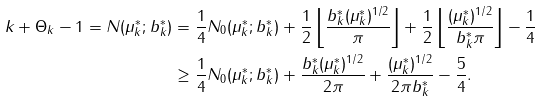Convert formula to latex. <formula><loc_0><loc_0><loc_500><loc_500>k + \Theta _ { k } - 1 = N ( \mu _ { k } ^ { * } ; b _ { k } ^ { * } ) & = \frac { 1 } { 4 } N _ { 0 } ( \mu _ { k } ^ { * } ; b _ { k } ^ { * } ) + \frac { 1 } { 2 } \left \lfloor \frac { { b _ { k } ^ { * } } ( \mu _ { k } ^ { * } ) ^ { 1 / 2 } } { \pi } \right \rfloor + \frac { 1 } { 2 } \left \lfloor \frac { ( \mu _ { k } ^ { * } ) ^ { 1 / 2 } } { b _ { k } ^ { * } \pi } \right \rfloor - \frac { 1 } { 4 } \\ & \geq \frac { 1 } { 4 } N _ { 0 } ( \mu _ { k } ^ { * } ; b _ { k } ^ { * } ) + \frac { b _ { k } ^ { * } ( \mu _ { k } ^ { * } ) ^ { 1 / 2 } } { 2 \pi } + \frac { ( \mu _ { k } ^ { * } ) ^ { 1 / 2 } } { 2 \pi b _ { k } ^ { * } } - \frac { 5 } { 4 } .</formula> 